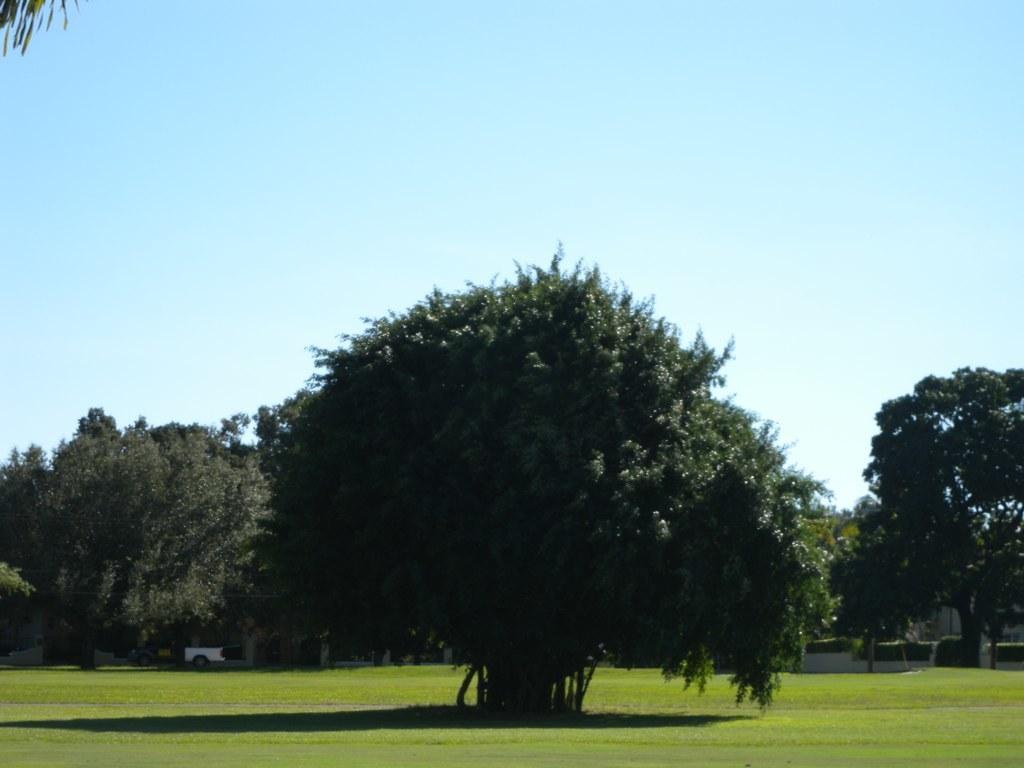Can you describe this image briefly? These are the trees with branches and leaves. This is the grass. In the background, that looks like a vehicle, which is parked. 